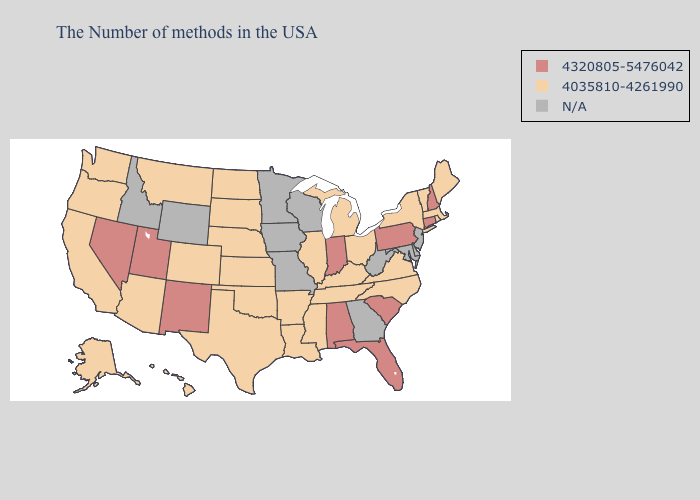What is the value of Nebraska?
Answer briefly. 4035810-4261990. Does the map have missing data?
Write a very short answer. Yes. What is the highest value in the West ?
Give a very brief answer. 4320805-5476042. What is the lowest value in the South?
Concise answer only. 4035810-4261990. Name the states that have a value in the range 4320805-5476042?
Keep it brief. New Hampshire, Connecticut, Pennsylvania, South Carolina, Florida, Indiana, Alabama, New Mexico, Utah, Nevada. What is the value of Kentucky?
Concise answer only. 4035810-4261990. Does Michigan have the highest value in the MidWest?
Short answer required. No. Name the states that have a value in the range N/A?
Concise answer only. New Jersey, Delaware, Maryland, West Virginia, Georgia, Wisconsin, Missouri, Minnesota, Iowa, Wyoming, Idaho. Among the states that border North Carolina , which have the lowest value?
Give a very brief answer. Virginia, Tennessee. What is the value of Delaware?
Concise answer only. N/A. Does the first symbol in the legend represent the smallest category?
Be succinct. No. Name the states that have a value in the range 4035810-4261990?
Concise answer only. Maine, Massachusetts, Rhode Island, Vermont, New York, Virginia, North Carolina, Ohio, Michigan, Kentucky, Tennessee, Illinois, Mississippi, Louisiana, Arkansas, Kansas, Nebraska, Oklahoma, Texas, South Dakota, North Dakota, Colorado, Montana, Arizona, California, Washington, Oregon, Alaska, Hawaii. 